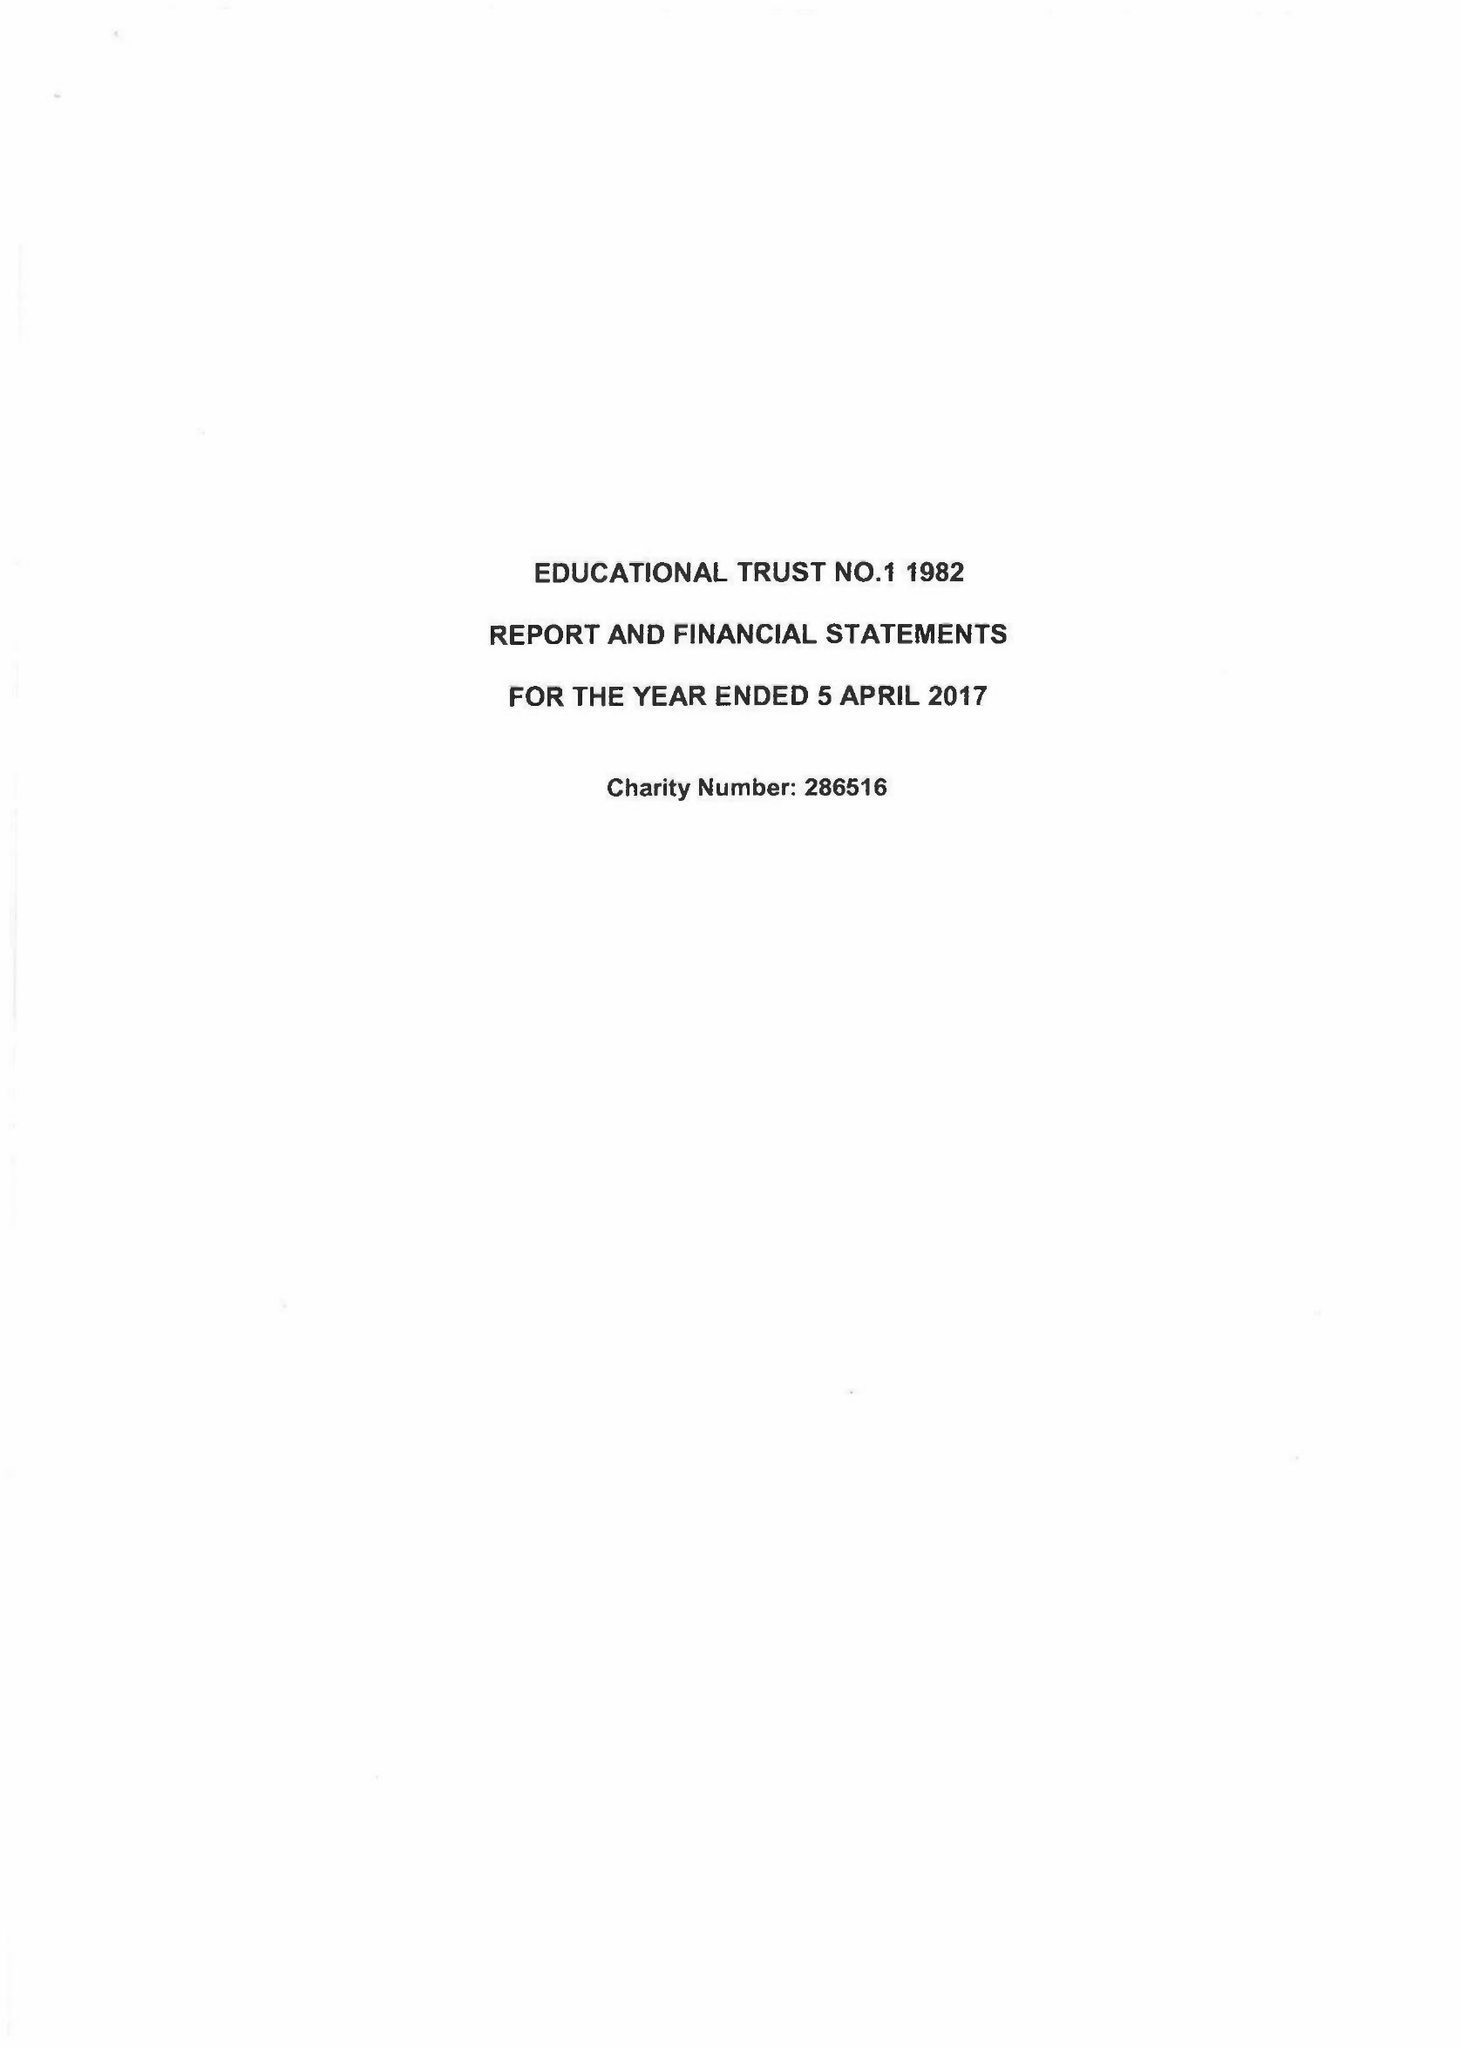What is the value for the address__postcode?
Answer the question using a single word or phrase. PO15 7PA 